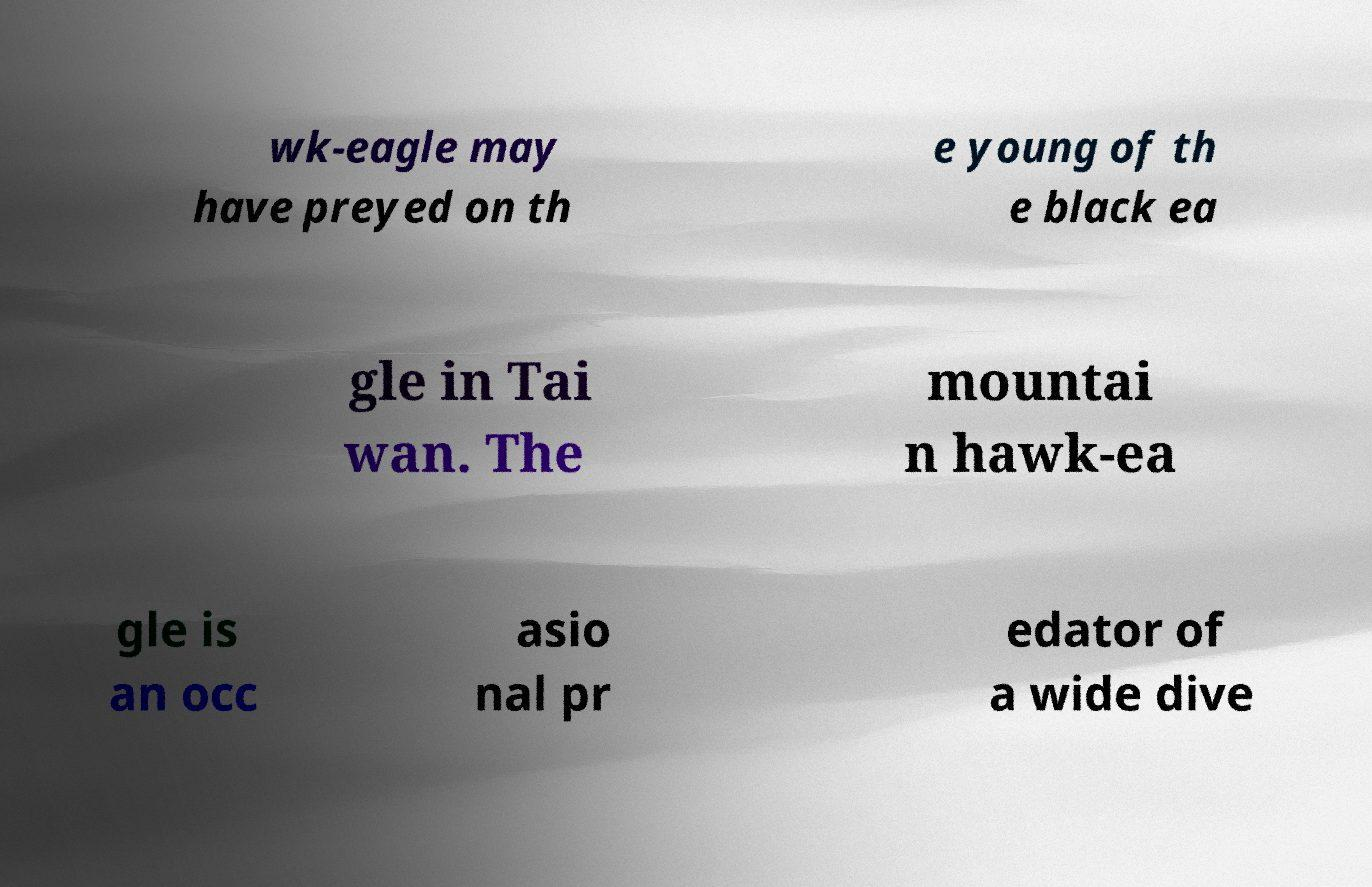What messages or text are displayed in this image? I need them in a readable, typed format. wk-eagle may have preyed on th e young of th e black ea gle in Tai wan. The mountai n hawk-ea gle is an occ asio nal pr edator of a wide dive 